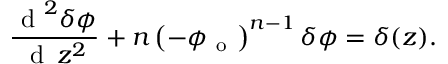<formula> <loc_0><loc_0><loc_500><loc_500>\frac { d ^ { 2 } \delta \phi } { d \, z ^ { 2 } } + n \left ( - \phi _ { o } \right ) ^ { n - 1 } \delta \phi = \delta ( z ) .</formula> 